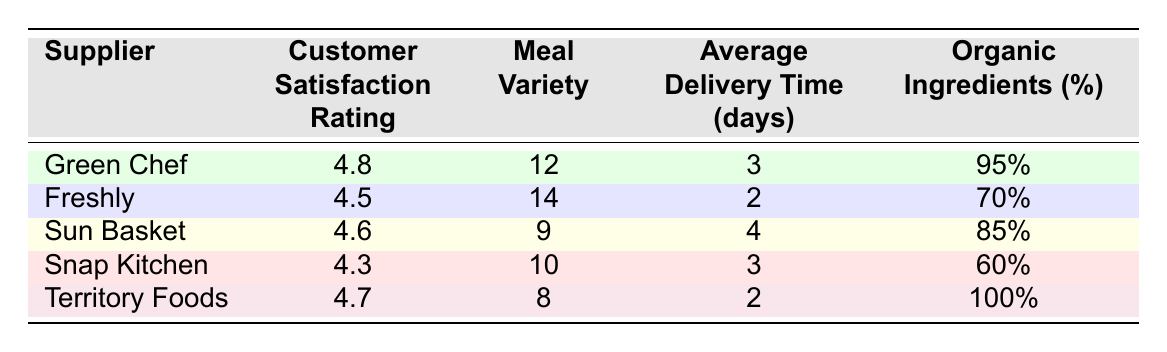What is the customer satisfaction rating of Green Chef? The customer satisfaction rating for Green Chef is explicitly listed in the table under that supplier's row, which states it is 4.8.
Answer: 4.8 Which supplier has the highest percentage of organic ingredients? By checking the organic ingredients percentage column, we see that Territory Foods has 100%, which is the highest when compared to the other suppliers listed.
Answer: Territory Foods What is the average delivery time among all suppliers? First, we sum the average delivery times: 3 + 2 + 4 + 3 + 2 = 14 days. Then, we divide by the number of suppliers, which is 5. Therefore, the average delivery time is 14 / 5 = 2.8 days.
Answer: 2.8 days Is the meal variety of Freshly greater than that of Snap Kitchen? Freshly has a meal variety of 14 whereas Snap Kitchen has 10. Since 14 is greater than 10, the statement is true.
Answer: Yes Which supplier has the lowest customer satisfaction rating? Looking at the customer satisfaction ratings in the table, Snap Kitchen has the lowest rating at 4.3 when compared to all other suppliers' ratings.
Answer: Snap Kitchen Do more meal varieties correlate with higher customer satisfaction ratings? We check the meal variety and customer satisfaction rating for each supplier. Freshly has the most variety (14) and a rating of 4.5, while Sun Basket has 9 varieties and a rating of 4.6. Snap Kitchen has 10 varieties and a rating of 4.3. This shows that a higher variety doesn't necessarily lead to a higher rating since Freshly has the most but not the highest rating.
Answer: No What percentage of organic ingredients does Sun Basket offer? The table directly indicates that Sun Basket offers 85% organic ingredients, so we can refer to that row to obtain the correct percentage.
Answer: 85% If you combine the customer satisfaction ratings of Green Chef and Territory Foods, what is their total? We add the customer satisfaction ratings: 4.8 (Green Chef) + 4.7 (Territory Foods) = 9.5.
Answer: 9.5 